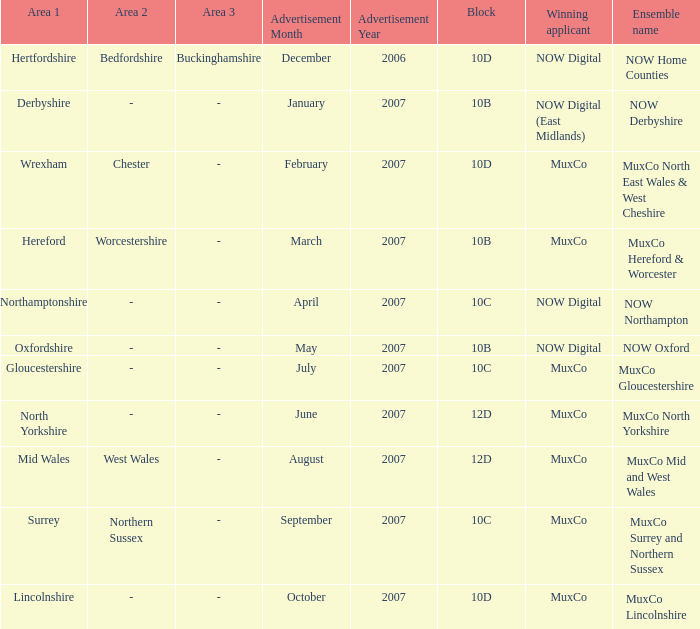Who is the Winning Applicant of Ensemble Name Muxco Lincolnshire in Block 10D? MuxCo. 